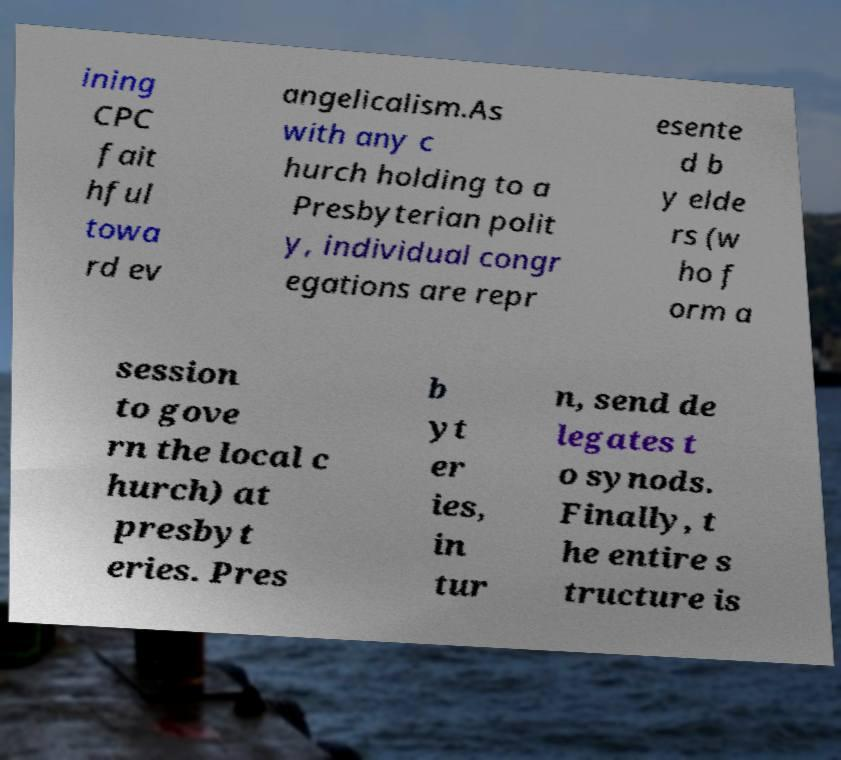Please identify and transcribe the text found in this image. ining CPC fait hful towa rd ev angelicalism.As with any c hurch holding to a Presbyterian polit y, individual congr egations are repr esente d b y elde rs (w ho f orm a session to gove rn the local c hurch) at presbyt eries. Pres b yt er ies, in tur n, send de legates t o synods. Finally, t he entire s tructure is 